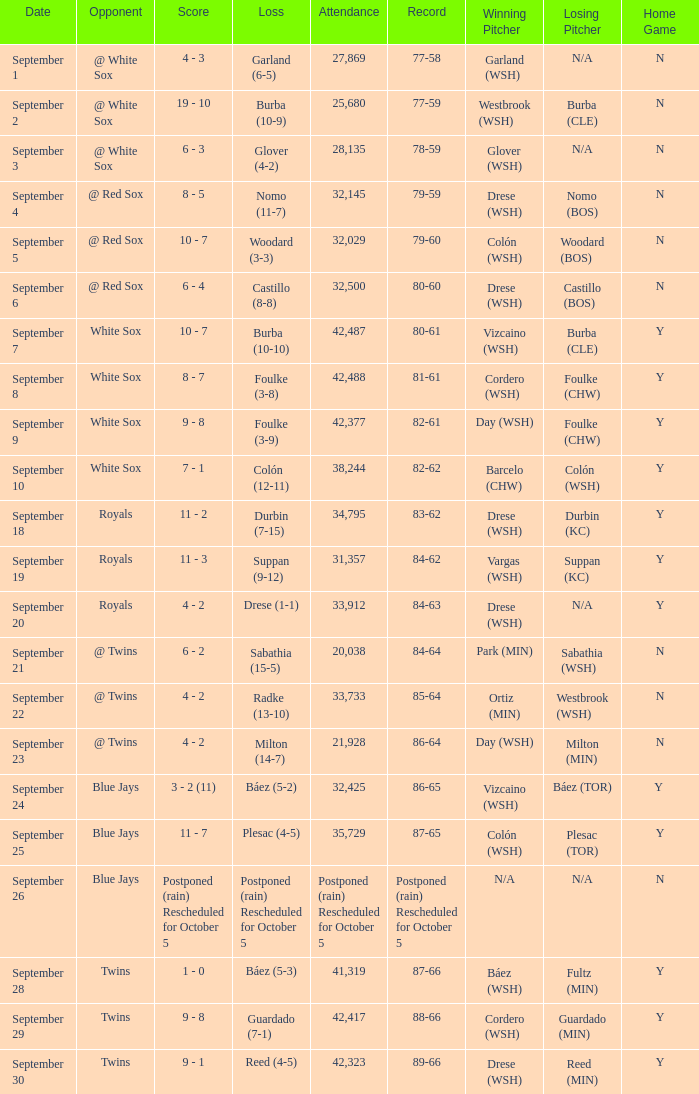What is the score of the game that holds a record of 80-61? 10 - 7. 